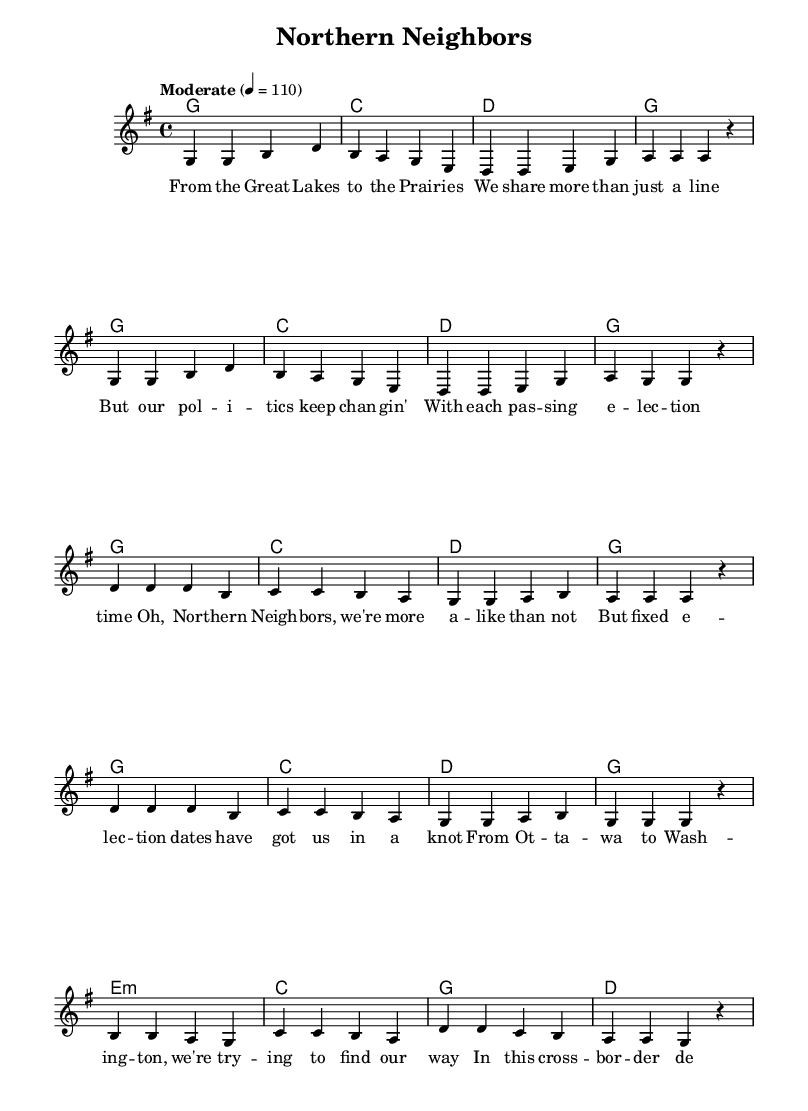What is the key signature of this music? The key signature is G major, which has one sharp (F#). This can be identified by looking at the key signature section at the beginning of the score.
Answer: G major What is the time signature of this music? The time signature is 4/4, which indicates four beats in each measure and a quarter note gets one beat. This is indicated at the start of the score.
Answer: 4/4 What is the tempo marking of the music? The tempo marking is "Moderate" with a beat of 110. This indicates a moderate pace for playing the piece and can be found in the tempo expression near the beginning of the score.
Answer: Moderate 4 = 110 How many measures are in the chorus section? The chorus consists of four measures, which can be counted by locating the corresponding musical phrases in the score. The chorus is repeated twice, giving a total of eight measures, but the question asks specifically for one instance.
Answer: 4 What musical form does this piece follow? The piece follows a verse-chorus-bridge structure, which is typical of contemporary country music. This can be inferred by looking at how the sections are labeled in the score with lyrics corresponding to each section.
Answer: Verse-Chorus-Bridge In the bridge, what rhythmic pattern is used? The bridge uses a consistent quarter note rhythm throughout the measure, indicating a simple and steady pace in line with typical country music feel. The notes are evenly spaced, which reflects this rhythm.
Answer: Quarter notes What political theme is addressed in the lyrics? The lyrics address the issues surrounding fixed election dates and the political connection between Canada and the United States. This theme can be derived from analyzing the text in the chorus which mentions "fixed election dates" and “cross-border democracy.”
Answer: Fixed election dates 